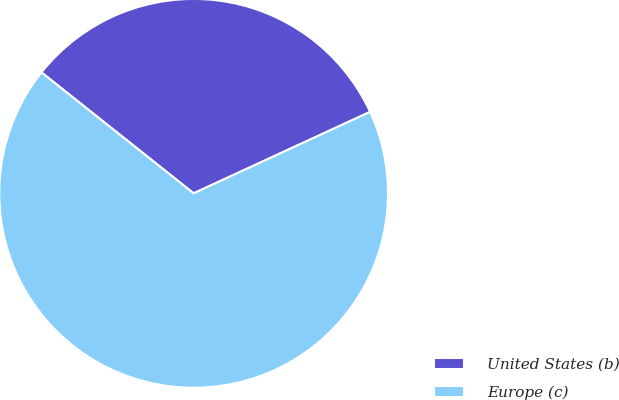Convert chart to OTSL. <chart><loc_0><loc_0><loc_500><loc_500><pie_chart><fcel>United States (b)<fcel>Europe (c)<nl><fcel>32.43%<fcel>67.57%<nl></chart> 